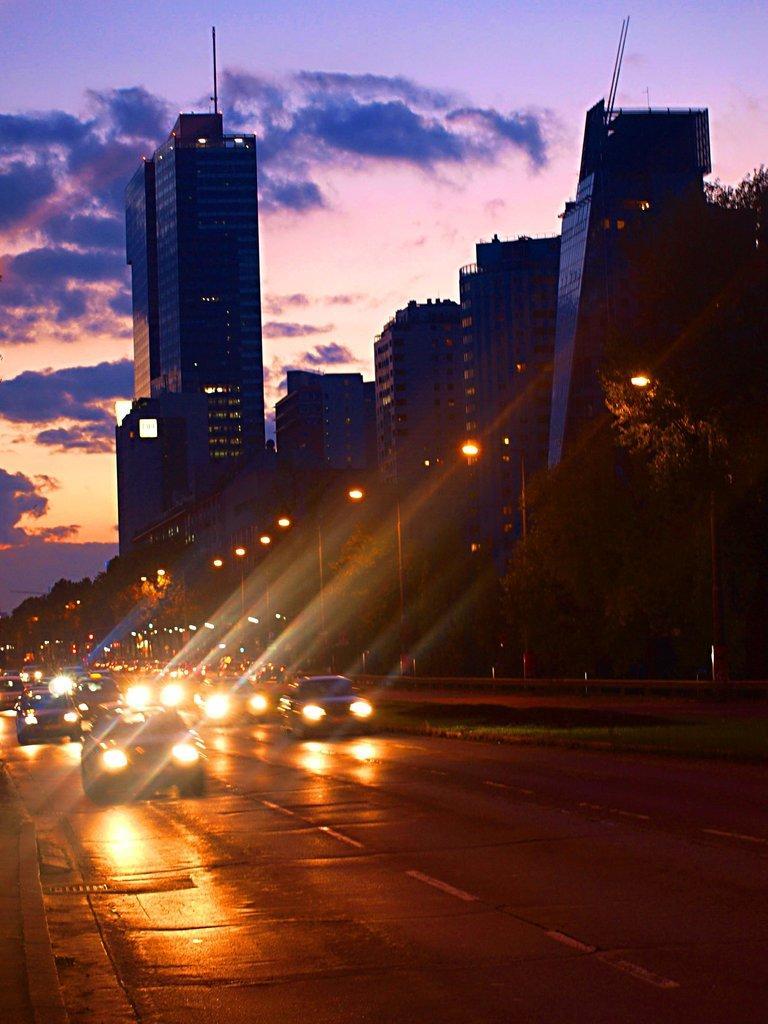Describe this image in one or two sentences. In this picture we can see some vehicles on the road and on the right side of the vehicles there are poles with lights and buildings. Behind the buildings there is a cloudy sky. 